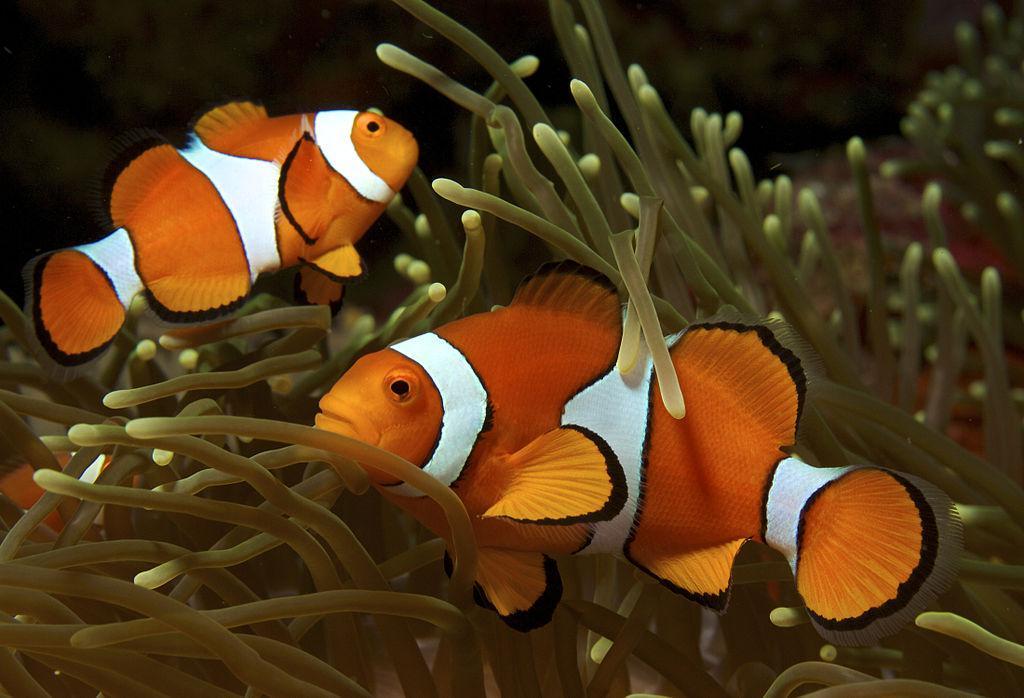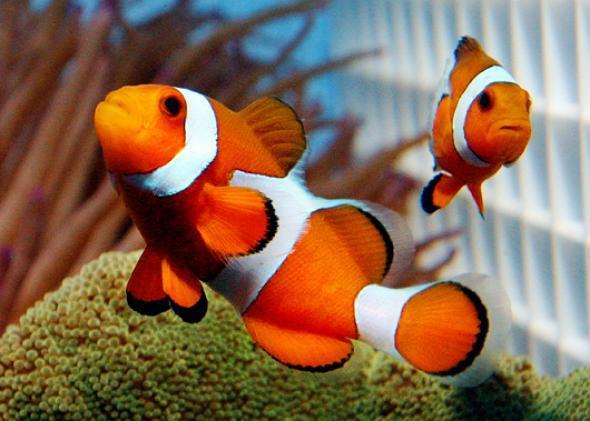The first image is the image on the left, the second image is the image on the right. Examine the images to the left and right. Is the description "At least one image has more than one clown fish." accurate? Answer yes or no. Yes. 